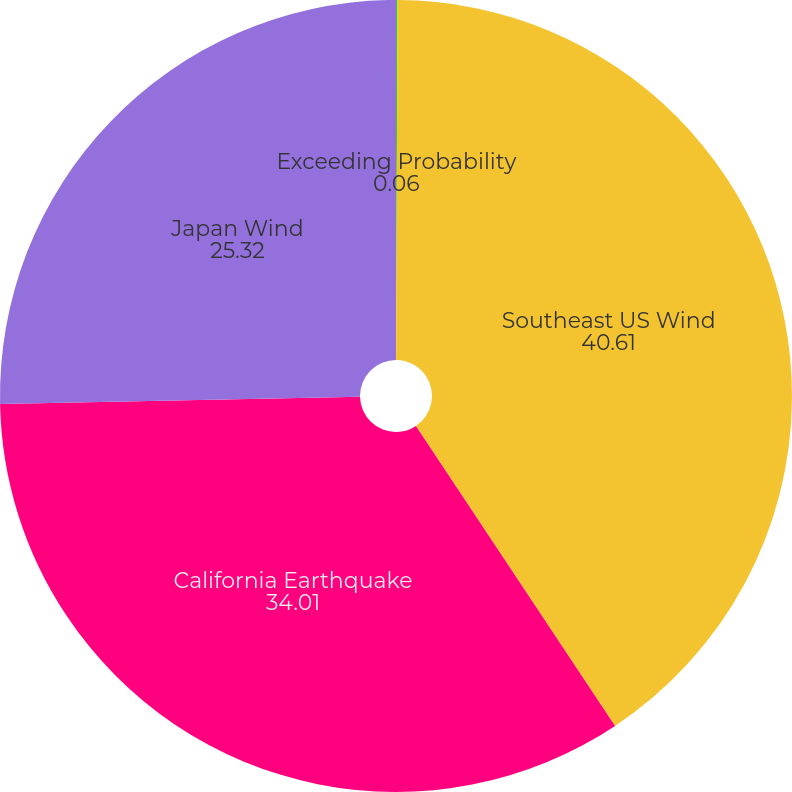<chart> <loc_0><loc_0><loc_500><loc_500><pie_chart><fcel>Exceeding Probability<fcel>Southeast US Wind<fcel>California Earthquake<fcel>Japan Wind<nl><fcel>0.06%<fcel>40.61%<fcel>34.01%<fcel>25.32%<nl></chart> 